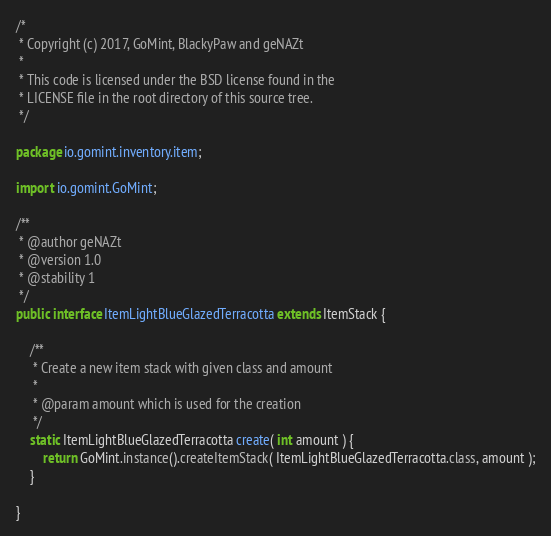Convert code to text. <code><loc_0><loc_0><loc_500><loc_500><_Java_>/*
 * Copyright (c) 2017, GoMint, BlackyPaw and geNAZt
 *
 * This code is licensed under the BSD license found in the
 * LICENSE file in the root directory of this source tree.
 */

package io.gomint.inventory.item;

import io.gomint.GoMint;

/**
 * @author geNAZt
 * @version 1.0
 * @stability 1
 */
public interface ItemLightBlueGlazedTerracotta extends ItemStack {

    /**
     * Create a new item stack with given class and amount
     *
     * @param amount which is used for the creation
     */
    static ItemLightBlueGlazedTerracotta create( int amount ) {
        return GoMint.instance().createItemStack( ItemLightBlueGlazedTerracotta.class, amount );
    }

}
</code> 